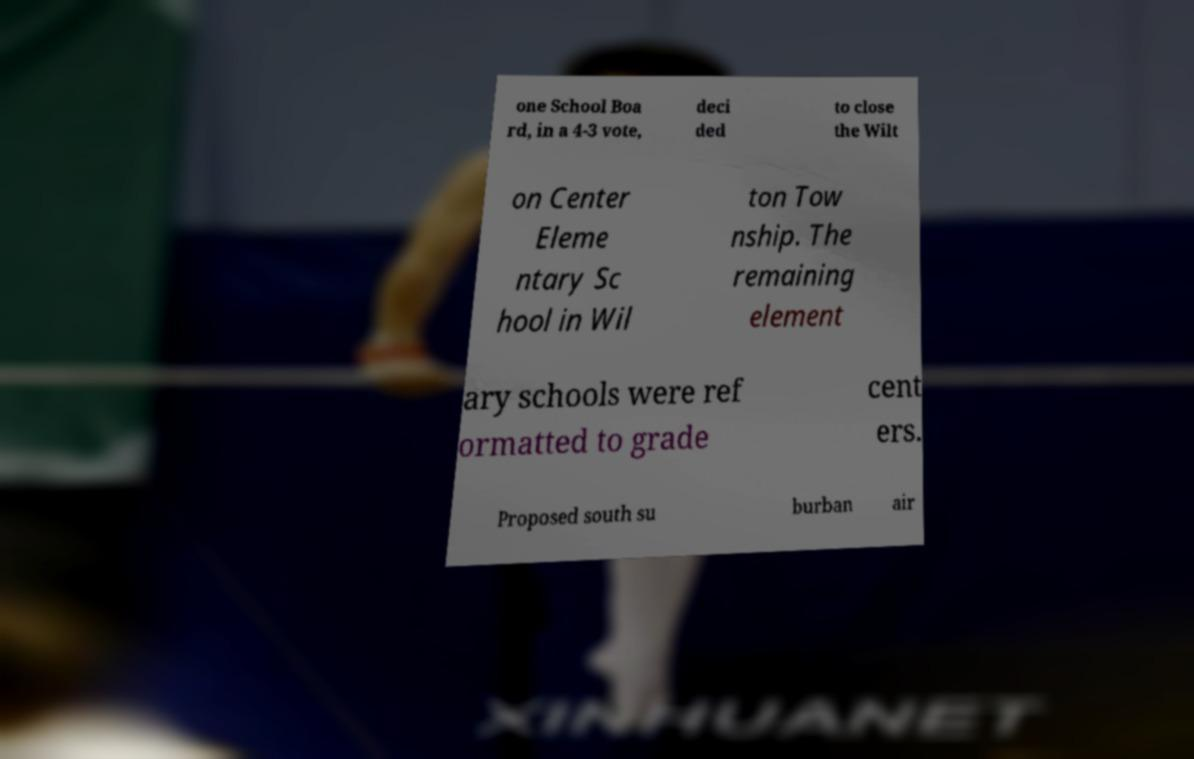Could you assist in decoding the text presented in this image and type it out clearly? one School Boa rd, in a 4-3 vote, deci ded to close the Wilt on Center Eleme ntary Sc hool in Wil ton Tow nship. The remaining element ary schools were ref ormatted to grade cent ers. Proposed south su burban air 